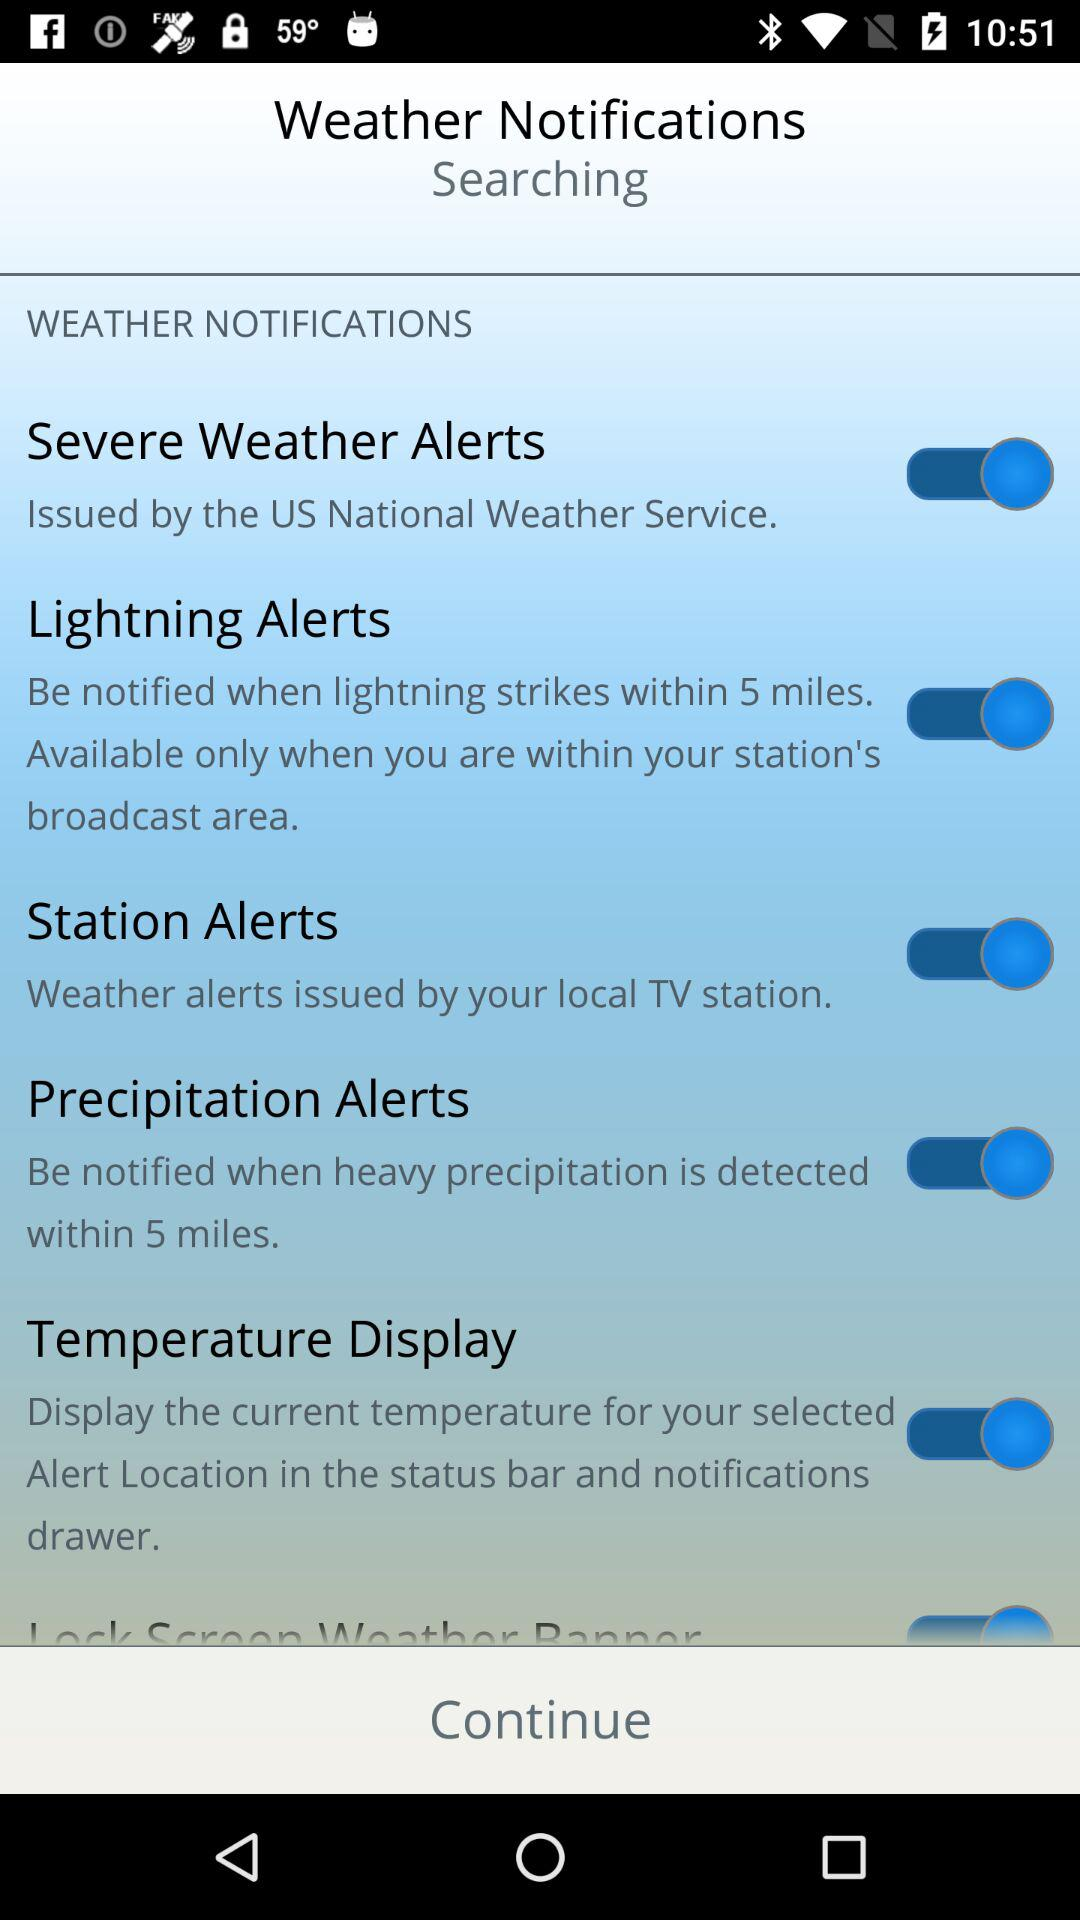Who issues severe weather alerts? The severe weather alerts are issued by the US National Weather Service. 